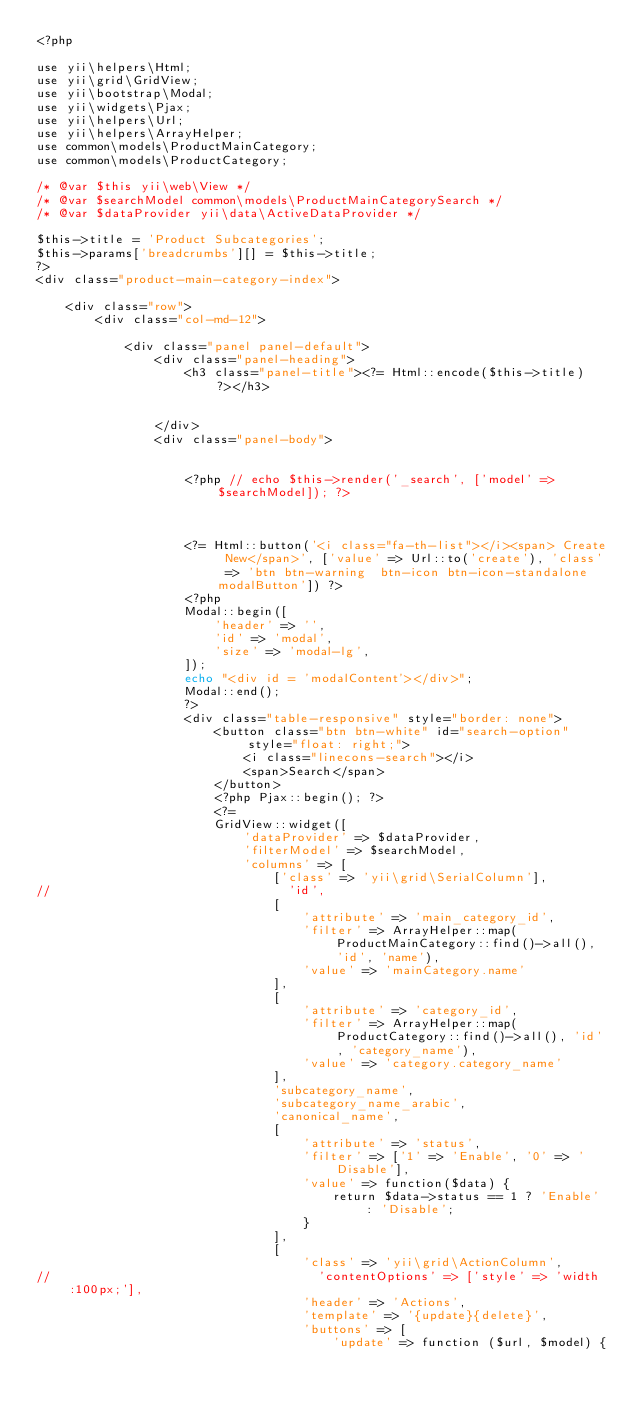Convert code to text. <code><loc_0><loc_0><loc_500><loc_500><_PHP_><?php

use yii\helpers\Html;
use yii\grid\GridView;
use yii\bootstrap\Modal;
use yii\widgets\Pjax;
use yii\helpers\Url;
use yii\helpers\ArrayHelper;
use common\models\ProductMainCategory;
use common\models\ProductCategory;

/* @var $this yii\web\View */
/* @var $searchModel common\models\ProductMainCategorySearch */
/* @var $dataProvider yii\data\ActiveDataProvider */

$this->title = 'Product Subcategories';
$this->params['breadcrumbs'][] = $this->title;
?>
<div class="product-main-category-index">

    <div class="row">
        <div class="col-md-12">

            <div class="panel panel-default">
                <div class="panel-heading">
                    <h3 class="panel-title"><?= Html::encode($this->title) ?></h3>


                </div>
                <div class="panel-body">


                    <?php // echo $this->render('_search', ['model' => $searchModel]); ?>



                    <?= Html::button('<i class="fa-th-list"></i><span> Create New</span>', ['value' => Url::to('create'), 'class' => 'btn btn-warning  btn-icon btn-icon-standalone modalButton']) ?>
                    <?php
                    Modal::begin([
                        'header' => '',
                        'id' => 'modal',
                        'size' => 'modal-lg',
                    ]);
                    echo "<div id = 'modalContent'></div>";
                    Modal::end();
                    ?>
                    <div class="table-responsive" style="border: none">
                        <button class="btn btn-white" id="search-option" style="float: right;">
                            <i class="linecons-search"></i>
                            <span>Search</span>
                        </button>
                        <?php Pjax::begin(); ?>
                        <?=
                        GridView::widget([
                            'dataProvider' => $dataProvider,
                            'filterModel' => $searchModel,
                            'columns' => [
                                ['class' => 'yii\grid\SerialColumn'],
//                                'id',
                                [
                                    'attribute' => 'main_category_id',
                                    'filter' => ArrayHelper::map(ProductMainCategory::find()->all(), 'id', 'name'),
                                    'value' => 'mainCategory.name'
                                ],
                                [
                                    'attribute' => 'category_id',
                                    'filter' => ArrayHelper::map(ProductCategory::find()->all(), 'id', 'category_name'),
                                    'value' => 'category.category_name'
                                ],
                                'subcategory_name',
                                'subcategory_name_arabic',
                                'canonical_name',
                                [
                                    'attribute' => 'status',
                                    'filter' => ['1' => 'Enable', '0' => 'Disable'],
                                    'value' => function($data) {
                                        return $data->status == 1 ? 'Enable' : 'Disable';
                                    }
                                ],
                                [
                                    'class' => 'yii\grid\ActionColumn',
//                                    'contentOptions' => ['style' => 'width:100px;'],
                                    'header' => 'Actions',
                                    'template' => '{update}{delete}',
                                    'buttons' => [
                                        'update' => function ($url, $model) {</code> 